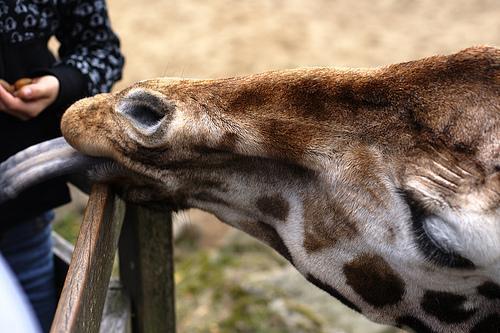How many giraffes?
Give a very brief answer. 1. 